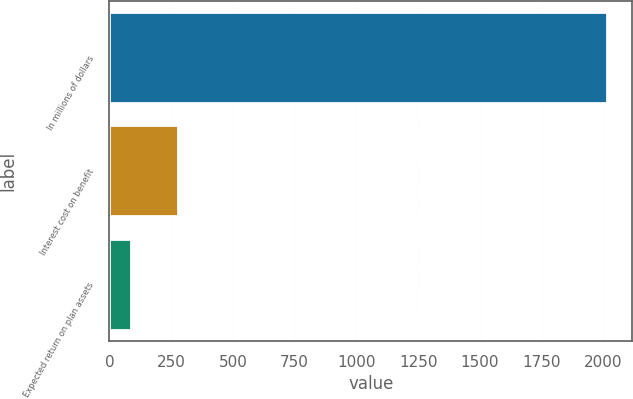Convert chart to OTSL. <chart><loc_0><loc_0><loc_500><loc_500><bar_chart><fcel>In millions of dollars<fcel>Interest cost on benefit<fcel>Expected return on plan assets<nl><fcel>2016<fcel>279<fcel>86<nl></chart> 